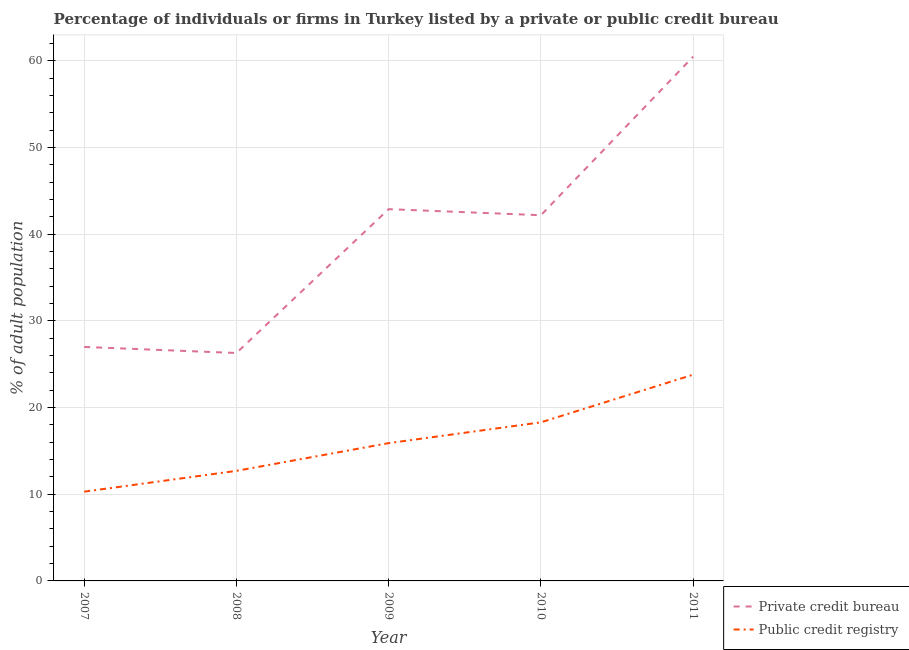What is the percentage of firms listed by private credit bureau in 2008?
Your response must be concise. 26.3. Across all years, what is the maximum percentage of firms listed by public credit bureau?
Provide a succinct answer. 23.8. In which year was the percentage of firms listed by private credit bureau maximum?
Ensure brevity in your answer.  2011. In which year was the percentage of firms listed by public credit bureau minimum?
Offer a very short reply. 2007. What is the difference between the percentage of firms listed by private credit bureau in 2009 and that in 2011?
Offer a terse response. -17.6. What is the difference between the percentage of firms listed by public credit bureau in 2011 and the percentage of firms listed by private credit bureau in 2007?
Your answer should be very brief. -3.2. What is the average percentage of firms listed by public credit bureau per year?
Keep it short and to the point. 16.2. In the year 2009, what is the difference between the percentage of firms listed by public credit bureau and percentage of firms listed by private credit bureau?
Your answer should be compact. -27. What is the ratio of the percentage of firms listed by private credit bureau in 2007 to that in 2010?
Ensure brevity in your answer.  0.64. Is the percentage of firms listed by private credit bureau in 2009 less than that in 2010?
Your answer should be compact. No. Is the difference between the percentage of firms listed by public credit bureau in 2007 and 2011 greater than the difference between the percentage of firms listed by private credit bureau in 2007 and 2011?
Offer a very short reply. Yes. Is the sum of the percentage of firms listed by private credit bureau in 2009 and 2010 greater than the maximum percentage of firms listed by public credit bureau across all years?
Provide a succinct answer. Yes. Does the percentage of firms listed by public credit bureau monotonically increase over the years?
Offer a very short reply. Yes. Is the percentage of firms listed by public credit bureau strictly less than the percentage of firms listed by private credit bureau over the years?
Offer a terse response. Yes. How many years are there in the graph?
Provide a succinct answer. 5. Are the values on the major ticks of Y-axis written in scientific E-notation?
Keep it short and to the point. No. Where does the legend appear in the graph?
Give a very brief answer. Bottom right. How are the legend labels stacked?
Provide a succinct answer. Vertical. What is the title of the graph?
Give a very brief answer. Percentage of individuals or firms in Turkey listed by a private or public credit bureau. What is the label or title of the Y-axis?
Your answer should be very brief. % of adult population. What is the % of adult population in Private credit bureau in 2007?
Offer a very short reply. 27. What is the % of adult population of Public credit registry in 2007?
Your answer should be very brief. 10.3. What is the % of adult population of Private credit bureau in 2008?
Ensure brevity in your answer.  26.3. What is the % of adult population of Private credit bureau in 2009?
Your answer should be compact. 42.9. What is the % of adult population of Private credit bureau in 2010?
Make the answer very short. 42.2. What is the % of adult population in Public credit registry in 2010?
Give a very brief answer. 18.3. What is the % of adult population in Private credit bureau in 2011?
Give a very brief answer. 60.5. What is the % of adult population in Public credit registry in 2011?
Your answer should be very brief. 23.8. Across all years, what is the maximum % of adult population of Private credit bureau?
Ensure brevity in your answer.  60.5. Across all years, what is the maximum % of adult population in Public credit registry?
Offer a terse response. 23.8. Across all years, what is the minimum % of adult population in Private credit bureau?
Offer a terse response. 26.3. Across all years, what is the minimum % of adult population of Public credit registry?
Your response must be concise. 10.3. What is the total % of adult population in Private credit bureau in the graph?
Offer a very short reply. 198.9. What is the difference between the % of adult population of Private credit bureau in 2007 and that in 2008?
Offer a terse response. 0.7. What is the difference between the % of adult population of Private credit bureau in 2007 and that in 2009?
Make the answer very short. -15.9. What is the difference between the % of adult population in Private credit bureau in 2007 and that in 2010?
Provide a short and direct response. -15.2. What is the difference between the % of adult population in Private credit bureau in 2007 and that in 2011?
Your answer should be very brief. -33.5. What is the difference between the % of adult population of Private credit bureau in 2008 and that in 2009?
Make the answer very short. -16.6. What is the difference between the % of adult population in Public credit registry in 2008 and that in 2009?
Give a very brief answer. -3.2. What is the difference between the % of adult population in Private credit bureau in 2008 and that in 2010?
Your answer should be very brief. -15.9. What is the difference between the % of adult population of Private credit bureau in 2008 and that in 2011?
Keep it short and to the point. -34.2. What is the difference between the % of adult population in Public credit registry in 2008 and that in 2011?
Provide a short and direct response. -11.1. What is the difference between the % of adult population of Private credit bureau in 2009 and that in 2010?
Make the answer very short. 0.7. What is the difference between the % of adult population in Public credit registry in 2009 and that in 2010?
Your response must be concise. -2.4. What is the difference between the % of adult population in Private credit bureau in 2009 and that in 2011?
Make the answer very short. -17.6. What is the difference between the % of adult population of Public credit registry in 2009 and that in 2011?
Give a very brief answer. -7.9. What is the difference between the % of adult population of Private credit bureau in 2010 and that in 2011?
Provide a succinct answer. -18.3. What is the difference between the % of adult population in Public credit registry in 2010 and that in 2011?
Your response must be concise. -5.5. What is the difference between the % of adult population in Private credit bureau in 2007 and the % of adult population in Public credit registry in 2008?
Your answer should be very brief. 14.3. What is the difference between the % of adult population in Private credit bureau in 2007 and the % of adult population in Public credit registry in 2011?
Give a very brief answer. 3.2. What is the difference between the % of adult population in Private credit bureau in 2008 and the % of adult population in Public credit registry in 2009?
Your response must be concise. 10.4. What is the difference between the % of adult population in Private credit bureau in 2008 and the % of adult population in Public credit registry in 2010?
Your answer should be very brief. 8. What is the difference between the % of adult population in Private credit bureau in 2009 and the % of adult population in Public credit registry in 2010?
Keep it short and to the point. 24.6. What is the difference between the % of adult population in Private credit bureau in 2009 and the % of adult population in Public credit registry in 2011?
Offer a very short reply. 19.1. What is the average % of adult population of Private credit bureau per year?
Offer a terse response. 39.78. In the year 2008, what is the difference between the % of adult population of Private credit bureau and % of adult population of Public credit registry?
Your response must be concise. 13.6. In the year 2010, what is the difference between the % of adult population in Private credit bureau and % of adult population in Public credit registry?
Keep it short and to the point. 23.9. In the year 2011, what is the difference between the % of adult population in Private credit bureau and % of adult population in Public credit registry?
Make the answer very short. 36.7. What is the ratio of the % of adult population in Private credit bureau in 2007 to that in 2008?
Offer a terse response. 1.03. What is the ratio of the % of adult population of Public credit registry in 2007 to that in 2008?
Your response must be concise. 0.81. What is the ratio of the % of adult population in Private credit bureau in 2007 to that in 2009?
Your answer should be compact. 0.63. What is the ratio of the % of adult population in Public credit registry in 2007 to that in 2009?
Give a very brief answer. 0.65. What is the ratio of the % of adult population of Private credit bureau in 2007 to that in 2010?
Make the answer very short. 0.64. What is the ratio of the % of adult population of Public credit registry in 2007 to that in 2010?
Your answer should be very brief. 0.56. What is the ratio of the % of adult population in Private credit bureau in 2007 to that in 2011?
Offer a very short reply. 0.45. What is the ratio of the % of adult population of Public credit registry in 2007 to that in 2011?
Give a very brief answer. 0.43. What is the ratio of the % of adult population of Private credit bureau in 2008 to that in 2009?
Your response must be concise. 0.61. What is the ratio of the % of adult population of Public credit registry in 2008 to that in 2009?
Offer a very short reply. 0.8. What is the ratio of the % of adult population of Private credit bureau in 2008 to that in 2010?
Your answer should be very brief. 0.62. What is the ratio of the % of adult population in Public credit registry in 2008 to that in 2010?
Give a very brief answer. 0.69. What is the ratio of the % of adult population in Private credit bureau in 2008 to that in 2011?
Offer a very short reply. 0.43. What is the ratio of the % of adult population in Public credit registry in 2008 to that in 2011?
Your answer should be compact. 0.53. What is the ratio of the % of adult population in Private credit bureau in 2009 to that in 2010?
Provide a succinct answer. 1.02. What is the ratio of the % of adult population in Public credit registry in 2009 to that in 2010?
Ensure brevity in your answer.  0.87. What is the ratio of the % of adult population of Private credit bureau in 2009 to that in 2011?
Offer a terse response. 0.71. What is the ratio of the % of adult population in Public credit registry in 2009 to that in 2011?
Your response must be concise. 0.67. What is the ratio of the % of adult population of Private credit bureau in 2010 to that in 2011?
Offer a very short reply. 0.7. What is the ratio of the % of adult population of Public credit registry in 2010 to that in 2011?
Give a very brief answer. 0.77. What is the difference between the highest and the second highest % of adult population in Public credit registry?
Offer a terse response. 5.5. What is the difference between the highest and the lowest % of adult population in Private credit bureau?
Offer a very short reply. 34.2. What is the difference between the highest and the lowest % of adult population of Public credit registry?
Your response must be concise. 13.5. 